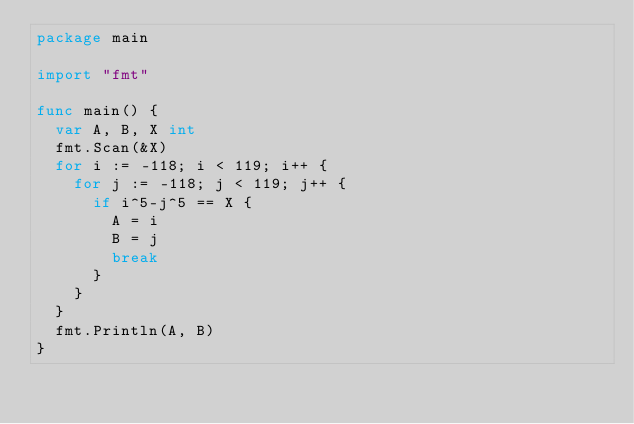<code> <loc_0><loc_0><loc_500><loc_500><_Go_>package main

import "fmt"

func main() {
	var A, B, X int
	fmt.Scan(&X)
	for i := -118; i < 119; i++ {
		for j := -118; j < 119; j++ {
			if i^5-j^5 == X {
				A = i
				B = j
				break
			}
		}
	}
	fmt.Println(A, B)
}
</code> 